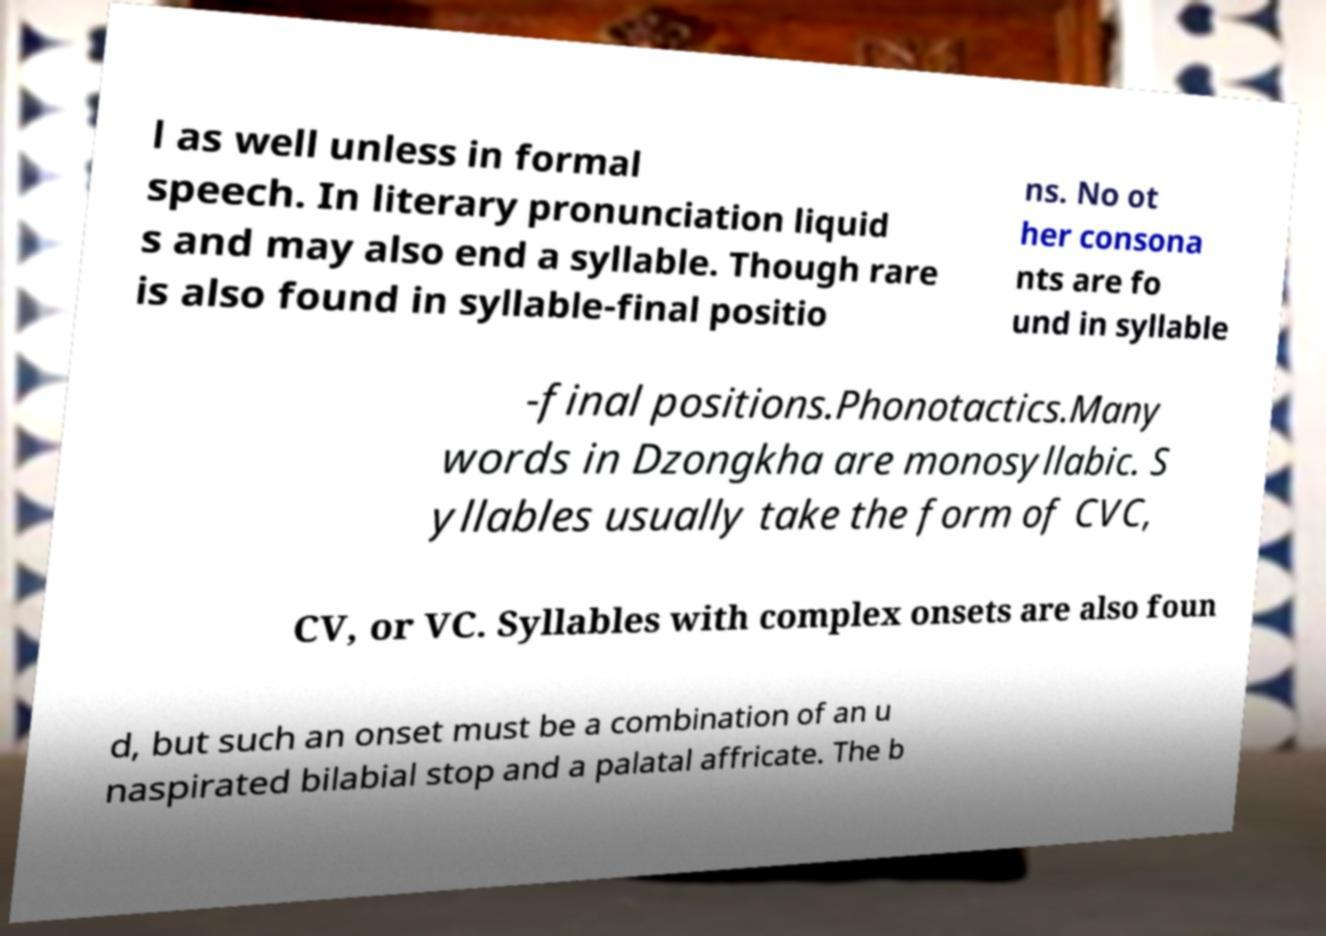Could you assist in decoding the text presented in this image and type it out clearly? l as well unless in formal speech. In literary pronunciation liquid s and may also end a syllable. Though rare is also found in syllable-final positio ns. No ot her consona nts are fo und in syllable -final positions.Phonotactics.Many words in Dzongkha are monosyllabic. S yllables usually take the form of CVC, CV, or VC. Syllables with complex onsets are also foun d, but such an onset must be a combination of an u naspirated bilabial stop and a palatal affricate. The b 